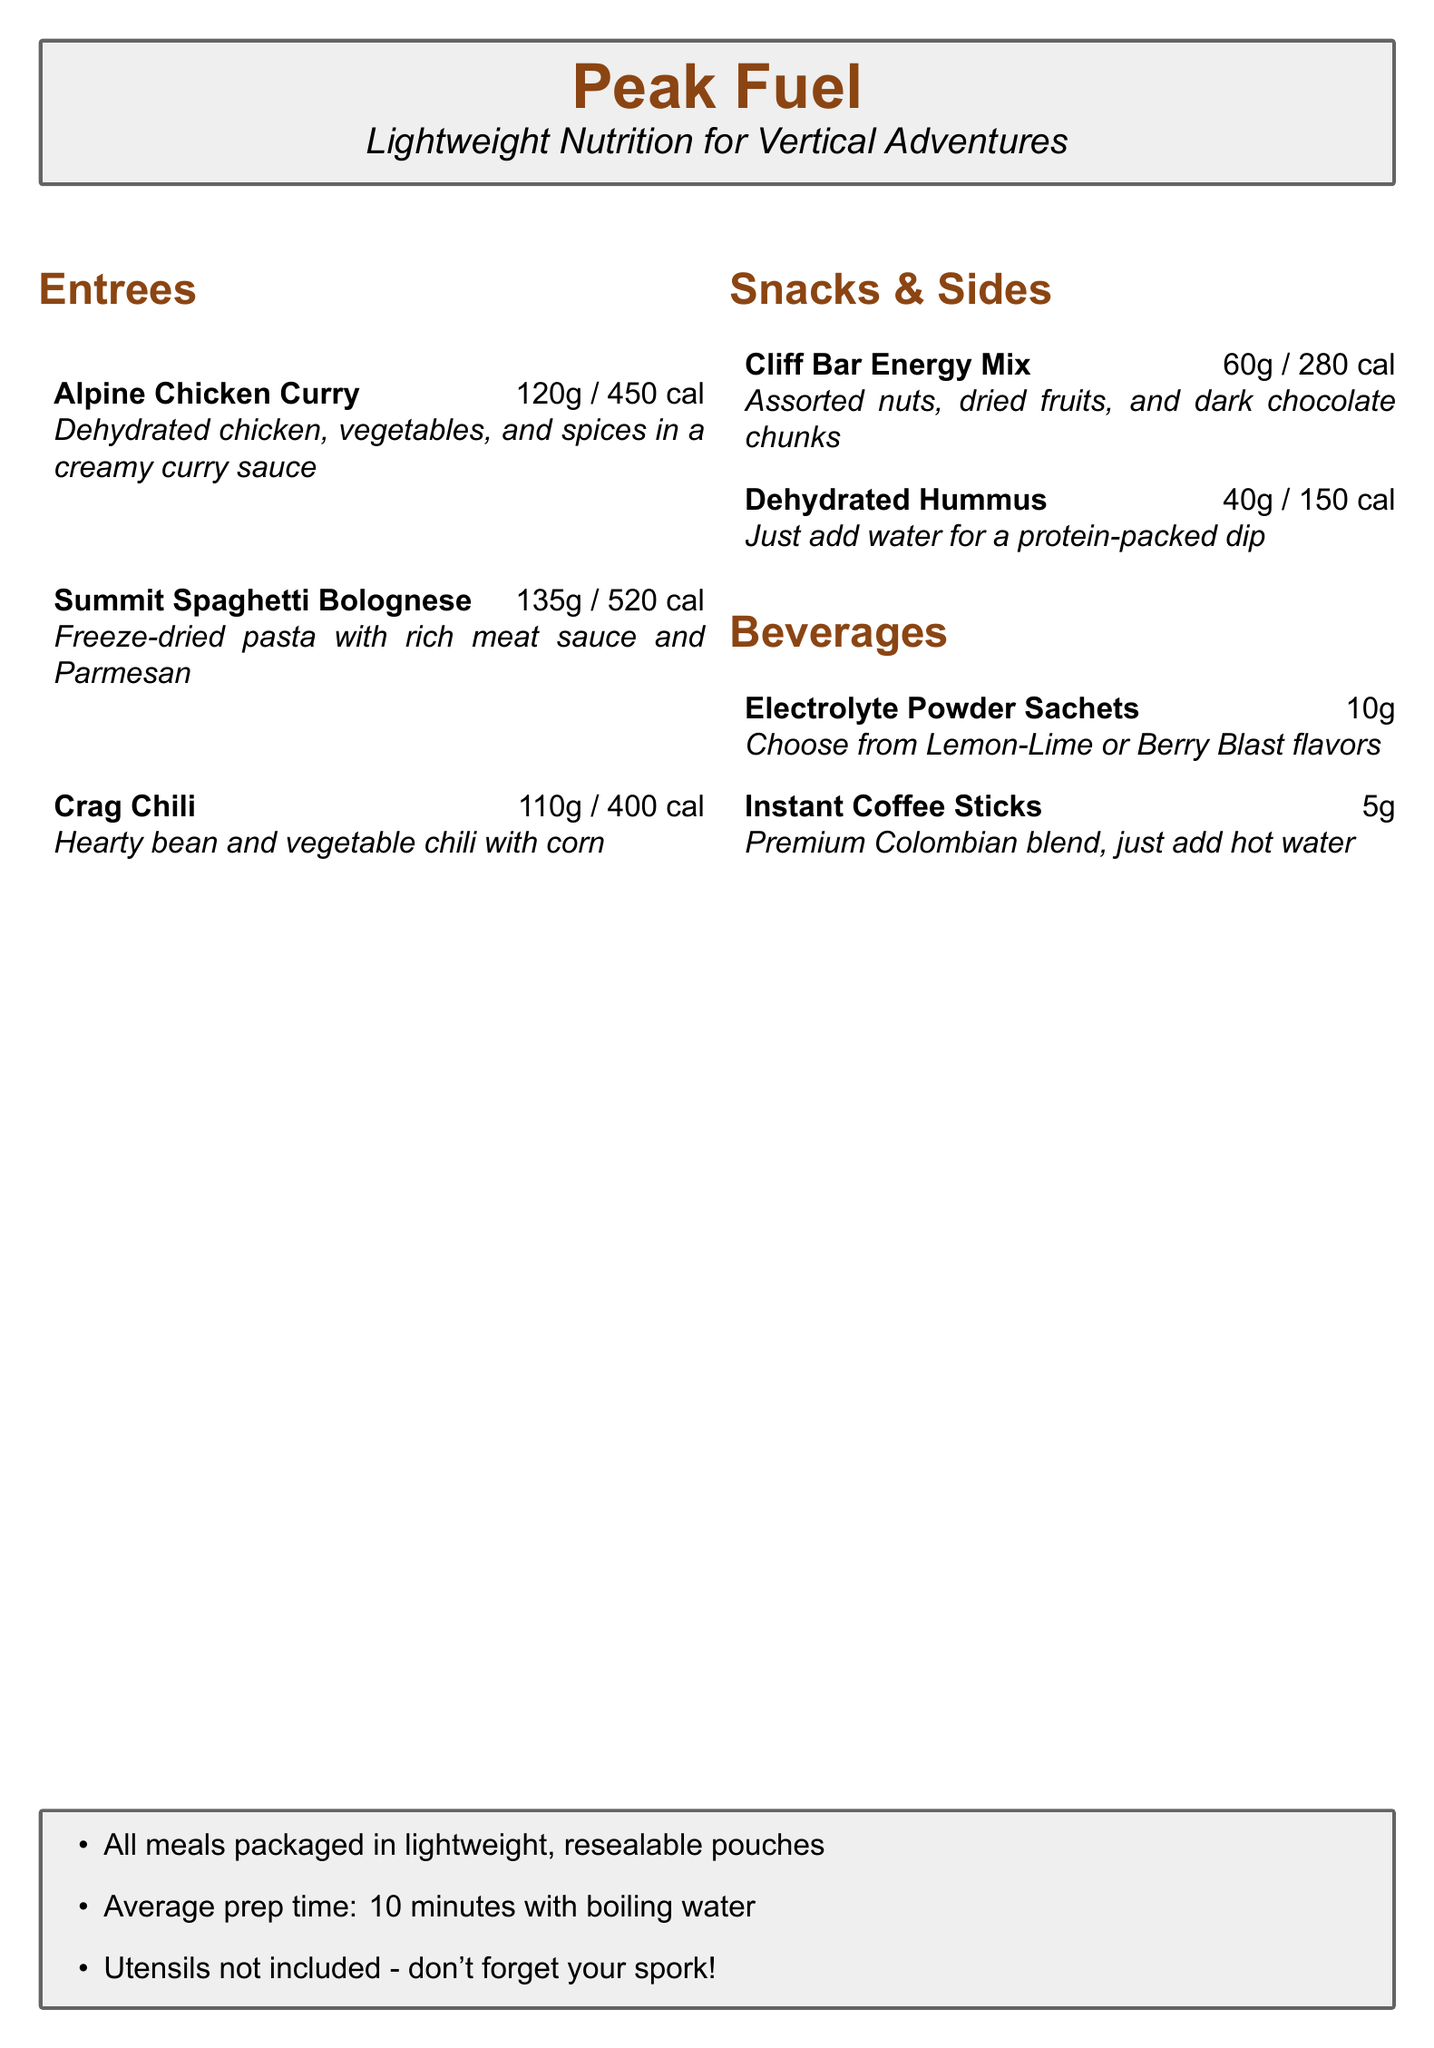What is the name of the menu? The menu is titled "Peak Fuel" for lightweight nutrition for climbers.
Answer: Peak Fuel How many calories are in the Summit Spaghetti Bolognese? The Summit Spaghetti Bolognese contains 520 calories as listed in the menu.
Answer: 520 cal What is the total weight of the Crag Chili? The weight of the Crag Chili is specified as 110 grams.
Answer: 110g What is the average prep time for the meals? The document states that the average preparation time for the meals is 10 minutes.
Answer: 10 minutes Which beverage has a premium Colombian blend? The beverage that has a premium Colombian blend is Instant Coffee Sticks, as mentioned in the menu.
Answer: Instant Coffee Sticks What type of meal is Alpine Chicken Curry? The Alpine Chicken Curry is classified as an entree in the menu.
Answer: Entree How are the meals packaged? The meals are packaged in lightweight, resealable pouches, according to the information provided.
Answer: Resealable pouches What is required to prepare the dehydrated meals? The document mentions the need for boiling water to prepare the dehydrated meals.
Answer: Boiling water 